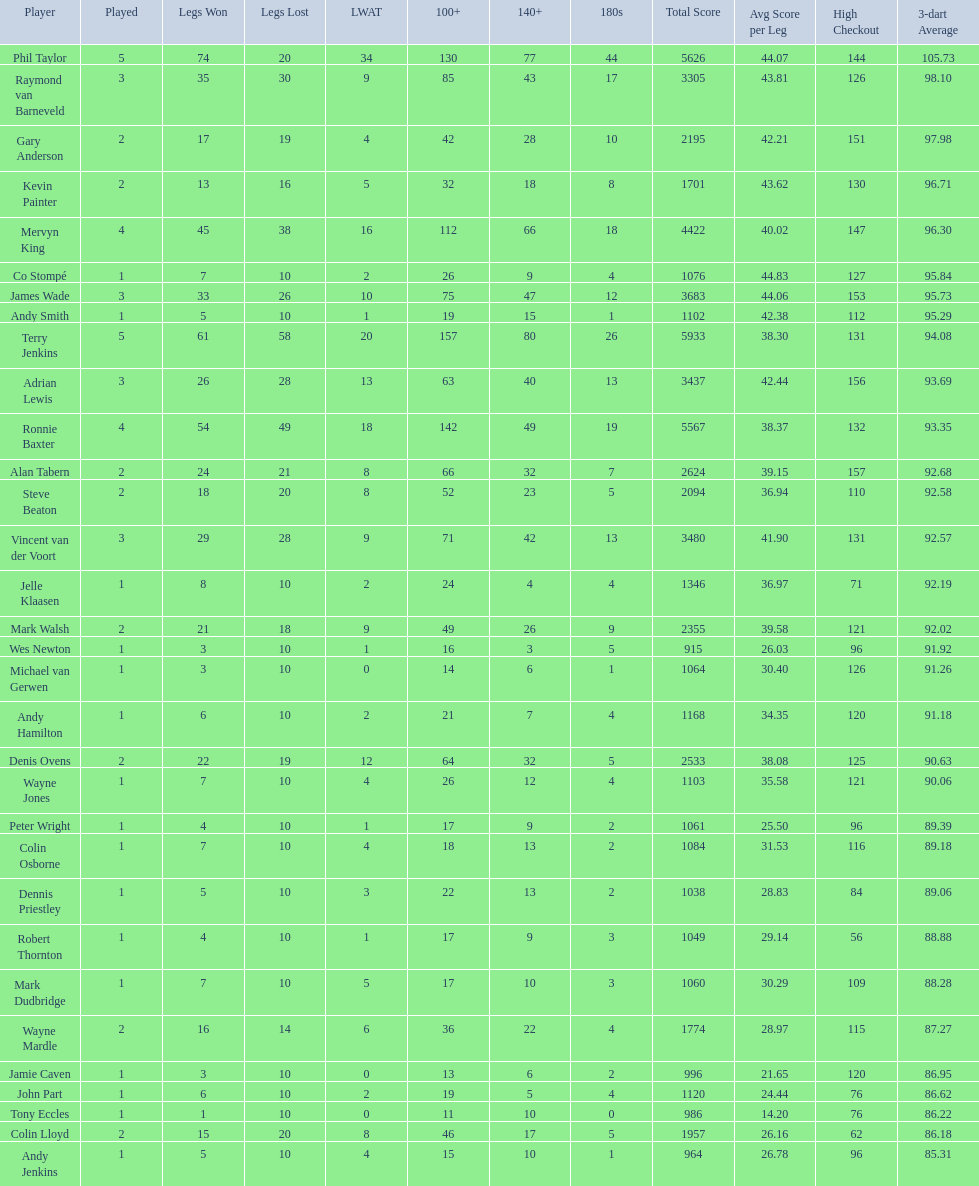List each of the players with a high checkout of 131. Terry Jenkins, Vincent van der Voort. 